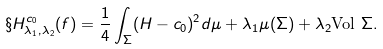<formula> <loc_0><loc_0><loc_500><loc_500>\S H ^ { c _ { 0 } } _ { \lambda _ { 1 } , \lambda _ { 2 } } ( f ) & = \frac { 1 } { 4 } \int _ { \Sigma } ( H - c _ { 0 } ) ^ { 2 } d \mu + \lambda _ { 1 } \mu ( \Sigma ) + \lambda _ { 2 } \text {Vol $\Sigma$} .</formula> 